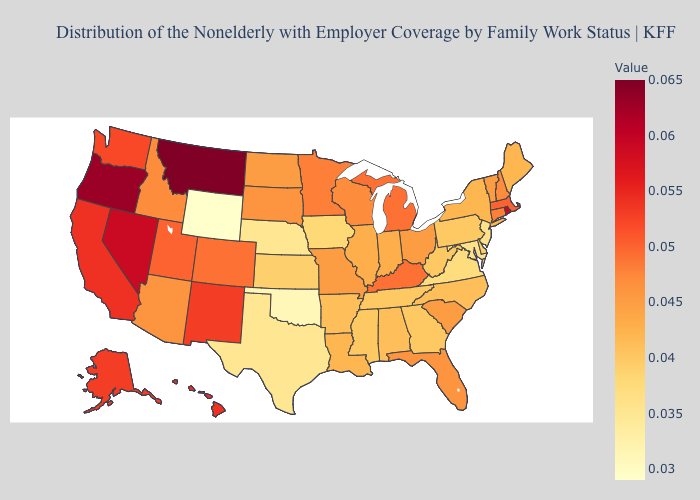Among the states that border Minnesota , does Iowa have the highest value?
Short answer required. No. Does the map have missing data?
Answer briefly. No. Is the legend a continuous bar?
Write a very short answer. Yes. 